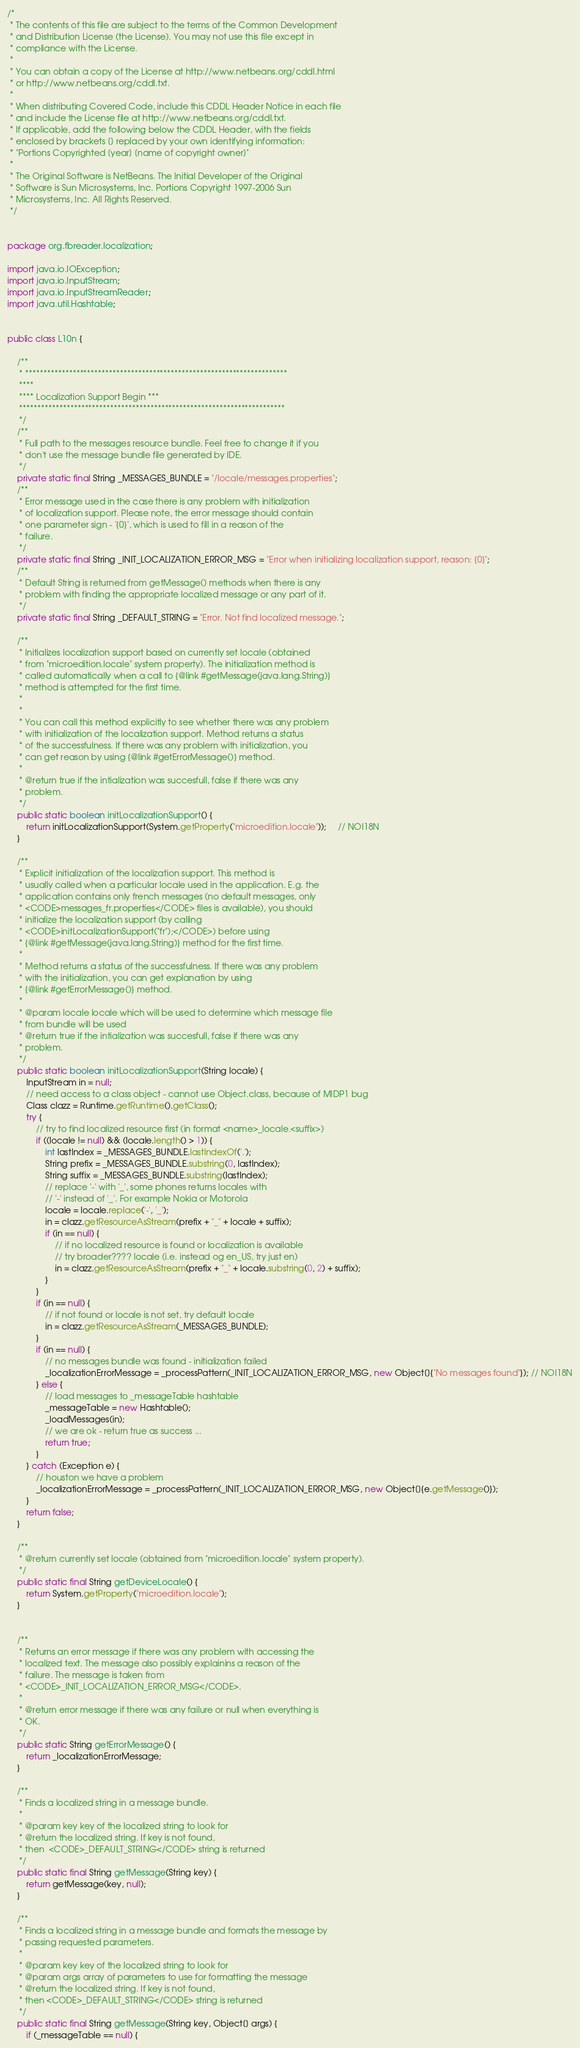Convert code to text. <code><loc_0><loc_0><loc_500><loc_500><_Java_>/*
 * The contents of this file are subject to the terms of the Common Development
 * and Distribution License (the License). You may not use this file except in
 * compliance with the License.
 *
 * You can obtain a copy of the License at http://www.netbeans.org/cddl.html
 * or http://www.netbeans.org/cddl.txt.
 *
 * When distributing Covered Code, include this CDDL Header Notice in each file
 * and include the License file at http://www.netbeans.org/cddl.txt.
 * If applicable, add the following below the CDDL Header, with the fields
 * enclosed by brackets [] replaced by your own identifying information:
 * "Portions Copyrighted [year] [name of copyright owner]"
 *
 * The Original Software is NetBeans. The Initial Developer of the Original
 * Software is Sun Microsystems, Inc. Portions Copyright 1997-2006 Sun
 * Microsystems, Inc. All Rights Reserved.
 */


package org.fbreader.localization;

import java.io.IOException;
import java.io.InputStream;
import java.io.InputStreamReader;
import java.util.Hashtable;


public class L10n {

    /**
     * ************************************************************************
     ****
     **** Localization Support Begin ***
     *************************************************************************
     */
    /**
     * Full path to the messages resource bundle. Feel free to change it if you
     * don't use the message bundle file generated by IDE.
     */    
    private static final String _MESSAGES_BUNDLE = "/locale/messages.properties";
    /**
     * Error message used in the case there is any problem with initialization
     * of localization support. Please note, the error message should contain
     * one parameter sign - '{0}', which is used to fill in a reason of the
     * failure.
     */    
    private static final String _INIT_LOCALIZATION_ERROR_MSG = "Error when initializing localization support, reason: {0}";
    /**
     * Default String is returned from getMessage() methods when there is any
     * problem with finding the appropriate localized message or any part of it.
     */    
    private static final String _DEFAULT_STRING = "Error. Not find localized message.";

    /**
     * Initializes localization support based on currently set locale (obtained
     * from "microedition.locale" system property). The initialization method is
     * called automatically when a call to {@link #getMessage(java.lang.String)}
     * method is attempted for the first time.
     *
     *
     * You can call this method explicitly to see whether there was any problem
     * with initialization of the localization support. Method returns a status
     * of the successfulness. If there was any problem with initialization, you
     * can get reason by using {@link #getErrorMessage()} method.
     *
     * @return true if the intialization was succesfull, false if there was any
     * problem.
     */    
    public static boolean initLocalizationSupport() {
        return initLocalizationSupport(System.getProperty("microedition.locale"));     // NOI18N
    }

    /**
     * Explicit initialization of the localization support. This method is
     * usually called when a particular locale used in the application. E.g. the
     * application contains only french messages (no default messages, only
     * <CODE>messages_fr.properties</CODE> files is available), you should
     * initialize the localization support (by calling
     * <CODE>initLocalizationSupport("fr");</CODE>) before using
     * {@link #getMessage(java.lang.String)} method for the first time.
     *
     * Method returns a status of the successfulness. If there was any problem
     * with the initialization, you can get explanation by using
     * {@link #getErrorMessage()} method.
     *
     * @param locale locale which will be used to determine which message file
     * from bundle will be used
     * @return true if the intialization was succesfull, false if there was any
     * problem.
     */    
    public static boolean initLocalizationSupport(String locale) {
        InputStream in = null;
        // need access to a class object - cannot use Object.class, because of MIDP1 bug
        Class clazz = Runtime.getRuntime().getClass();
        try {
            // try to find localized resource first (in format <name>_locale.<suffix>)
            if ((locale != null) && (locale.length() > 1)) {
                int lastIndex = _MESSAGES_BUNDLE.lastIndexOf('.');
                String prefix = _MESSAGES_BUNDLE.substring(0, lastIndex);
                String suffix = _MESSAGES_BUNDLE.substring(lastIndex);
                // replace '-' with '_', some phones returns locales with
                // '-' instead of '_'. For example Nokia or Motorola
                locale = locale.replace('-', '_');
                in = clazz.getResourceAsStream(prefix + "_" + locale + suffix);
                if (in == null) {
                    // if no localized resource is found or localization is available
                    // try broader???? locale (i.e. instead og en_US, try just en)
                    in = clazz.getResourceAsStream(prefix + "_" + locale.substring(0, 2) + suffix);                    
                }
            }            
            if (in == null) {
                // if not found or locale is not set, try default locale
                in = clazz.getResourceAsStream(_MESSAGES_BUNDLE);
            }            
            if (in == null) {
                // no messages bundle was found - initialization failed
                _localizationErrorMessage = _processPattern(_INIT_LOCALIZATION_ERROR_MSG, new Object[]{"No messages found"}); // NOI18N
            } else {
                // load messages to _messageTable hashtable
                _messageTable = new Hashtable();                
                _loadMessages(in);
                // we are ok - return true as success ...
                return true;
            }
        } catch (Exception e) {
            // houston we have a problem
            _localizationErrorMessage = _processPattern(_INIT_LOCALIZATION_ERROR_MSG, new Object[]{e.getMessage()});
        }
        return false;
    }
    
    /**
     * @return currently set locale (obtained from "microedition.locale" system property).
     */
    public static final String getDeviceLocale() {
        return System.getProperty("microedition.locale");
    }    
    

    /**
     * Returns an error message if there was any problem with accessing the
     * localized text. The message also possibly explainins a reason of the
     * failure. The message is taken from
     * <CODE>_INIT_LOCALIZATION_ERROR_MSG</CODE>.
     *
     * @return error message if there was any failure or null when everything is
     * OK.
     */    
    public static String getErrorMessage() {
        return _localizationErrorMessage;
    }

    /**
     * Finds a localized string in a message bundle.
     *
     * @param key key of the localized string to look for
     * @return the localized string. If key is not found,
     * then  <CODE>_DEFAULT_STRING</CODE> string is returned
     */    
    public static final String getMessage(String key) {
        return getMessage(key, null);
    }

    /**
     * Finds a localized string in a message bundle and formats the message by
     * passing requested parameters.
     *
     * @param key key of the localized string to look for
     * @param args array of parameters to use for formatting the message
     * @return the localized string. If key is not found,
     * then <CODE>_DEFAULT_STRING</CODE> string is returned
     */    
    public static final String getMessage(String key, Object[] args) {
        if (_messageTable == null) {</code> 